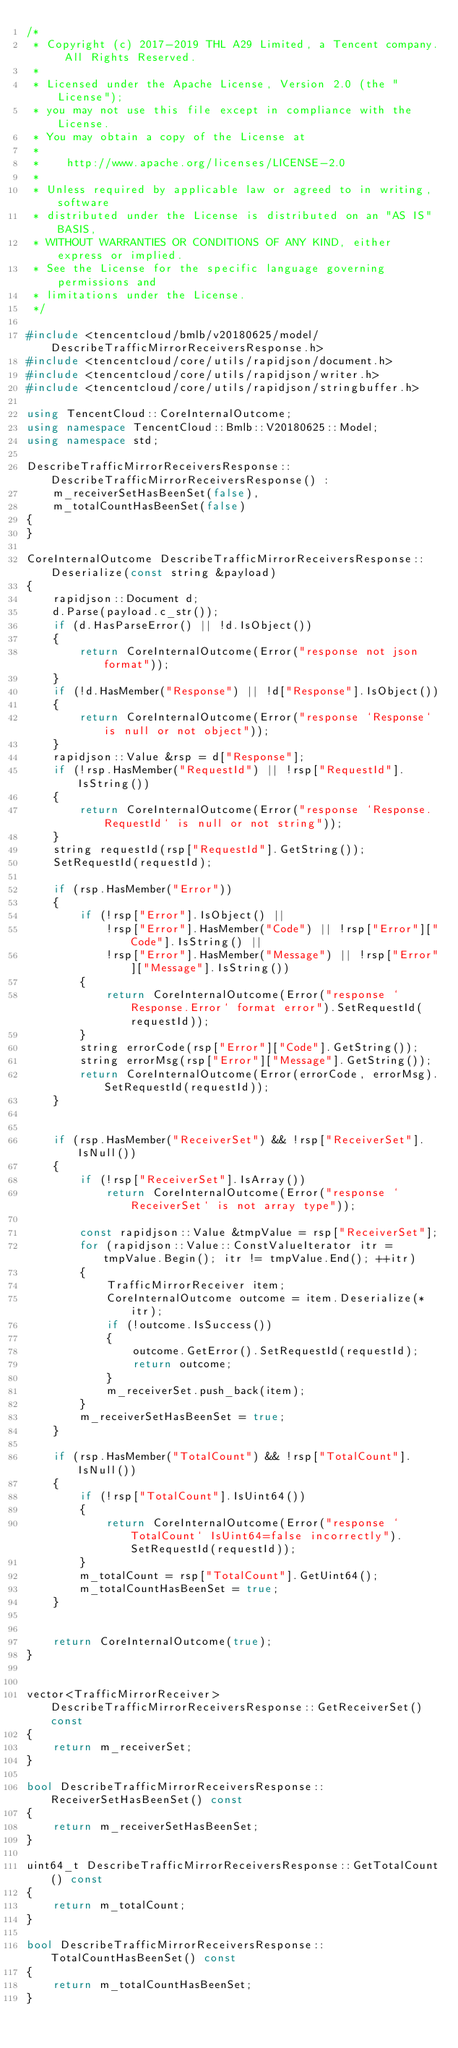<code> <loc_0><loc_0><loc_500><loc_500><_C++_>/*
 * Copyright (c) 2017-2019 THL A29 Limited, a Tencent company. All Rights Reserved.
 *
 * Licensed under the Apache License, Version 2.0 (the "License");
 * you may not use this file except in compliance with the License.
 * You may obtain a copy of the License at
 *
 *    http://www.apache.org/licenses/LICENSE-2.0
 *
 * Unless required by applicable law or agreed to in writing, software
 * distributed under the License is distributed on an "AS IS" BASIS,
 * WITHOUT WARRANTIES OR CONDITIONS OF ANY KIND, either express or implied.
 * See the License for the specific language governing permissions and
 * limitations under the License.
 */

#include <tencentcloud/bmlb/v20180625/model/DescribeTrafficMirrorReceiversResponse.h>
#include <tencentcloud/core/utils/rapidjson/document.h>
#include <tencentcloud/core/utils/rapidjson/writer.h>
#include <tencentcloud/core/utils/rapidjson/stringbuffer.h>

using TencentCloud::CoreInternalOutcome;
using namespace TencentCloud::Bmlb::V20180625::Model;
using namespace std;

DescribeTrafficMirrorReceiversResponse::DescribeTrafficMirrorReceiversResponse() :
    m_receiverSetHasBeenSet(false),
    m_totalCountHasBeenSet(false)
{
}

CoreInternalOutcome DescribeTrafficMirrorReceiversResponse::Deserialize(const string &payload)
{
    rapidjson::Document d;
    d.Parse(payload.c_str());
    if (d.HasParseError() || !d.IsObject())
    {
        return CoreInternalOutcome(Error("response not json format"));
    }
    if (!d.HasMember("Response") || !d["Response"].IsObject())
    {
        return CoreInternalOutcome(Error("response `Response` is null or not object"));
    }
    rapidjson::Value &rsp = d["Response"];
    if (!rsp.HasMember("RequestId") || !rsp["RequestId"].IsString())
    {
        return CoreInternalOutcome(Error("response `Response.RequestId` is null or not string"));
    }
    string requestId(rsp["RequestId"].GetString());
    SetRequestId(requestId);

    if (rsp.HasMember("Error"))
    {
        if (!rsp["Error"].IsObject() ||
            !rsp["Error"].HasMember("Code") || !rsp["Error"]["Code"].IsString() ||
            !rsp["Error"].HasMember("Message") || !rsp["Error"]["Message"].IsString())
        {
            return CoreInternalOutcome(Error("response `Response.Error` format error").SetRequestId(requestId));
        }
        string errorCode(rsp["Error"]["Code"].GetString());
        string errorMsg(rsp["Error"]["Message"].GetString());
        return CoreInternalOutcome(Error(errorCode, errorMsg).SetRequestId(requestId));
    }


    if (rsp.HasMember("ReceiverSet") && !rsp["ReceiverSet"].IsNull())
    {
        if (!rsp["ReceiverSet"].IsArray())
            return CoreInternalOutcome(Error("response `ReceiverSet` is not array type"));

        const rapidjson::Value &tmpValue = rsp["ReceiverSet"];
        for (rapidjson::Value::ConstValueIterator itr = tmpValue.Begin(); itr != tmpValue.End(); ++itr)
        {
            TrafficMirrorReceiver item;
            CoreInternalOutcome outcome = item.Deserialize(*itr);
            if (!outcome.IsSuccess())
            {
                outcome.GetError().SetRequestId(requestId);
                return outcome;
            }
            m_receiverSet.push_back(item);
        }
        m_receiverSetHasBeenSet = true;
    }

    if (rsp.HasMember("TotalCount") && !rsp["TotalCount"].IsNull())
    {
        if (!rsp["TotalCount"].IsUint64())
        {
            return CoreInternalOutcome(Error("response `TotalCount` IsUint64=false incorrectly").SetRequestId(requestId));
        }
        m_totalCount = rsp["TotalCount"].GetUint64();
        m_totalCountHasBeenSet = true;
    }


    return CoreInternalOutcome(true);
}


vector<TrafficMirrorReceiver> DescribeTrafficMirrorReceiversResponse::GetReceiverSet() const
{
    return m_receiverSet;
}

bool DescribeTrafficMirrorReceiversResponse::ReceiverSetHasBeenSet() const
{
    return m_receiverSetHasBeenSet;
}

uint64_t DescribeTrafficMirrorReceiversResponse::GetTotalCount() const
{
    return m_totalCount;
}

bool DescribeTrafficMirrorReceiversResponse::TotalCountHasBeenSet() const
{
    return m_totalCountHasBeenSet;
}


</code> 